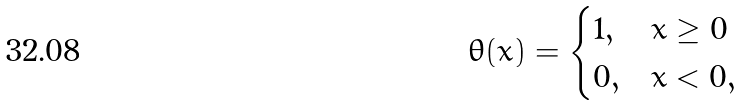Convert formula to latex. <formula><loc_0><loc_0><loc_500><loc_500>\theta ( x ) = \begin{cases} 1 , & x \geq 0 \\ 0 , & x < 0 , \end{cases}</formula> 